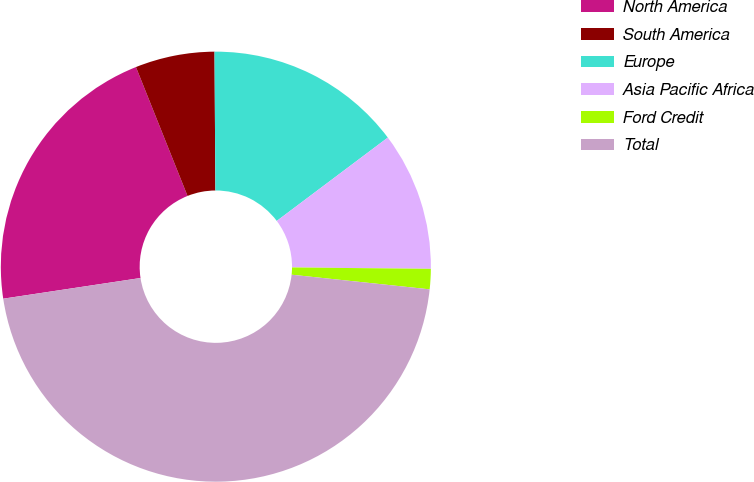<chart> <loc_0><loc_0><loc_500><loc_500><pie_chart><fcel>North America<fcel>South America<fcel>Europe<fcel>Asia Pacific Africa<fcel>Ford Credit<fcel>Total<nl><fcel>21.32%<fcel>5.96%<fcel>14.85%<fcel>10.41%<fcel>1.52%<fcel>45.94%<nl></chart> 